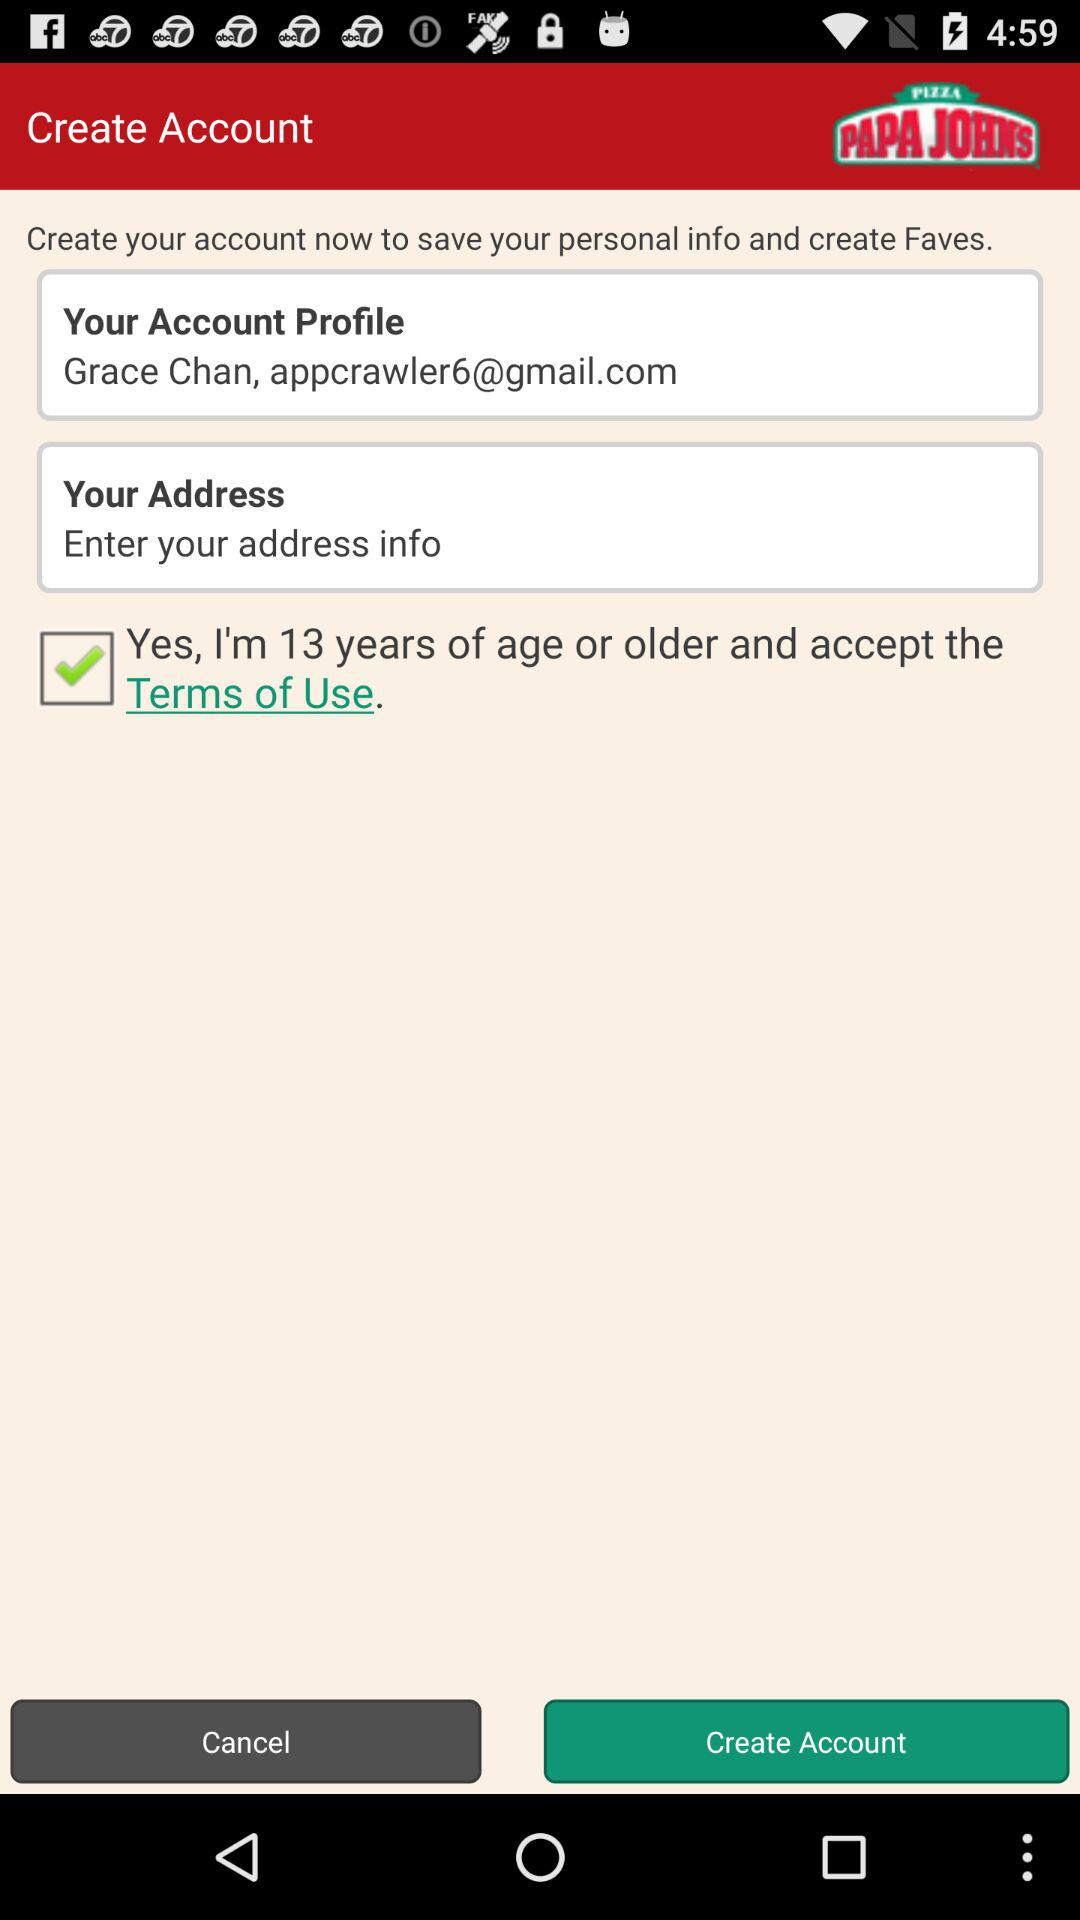What is the account profile? The account profile is Grace Chan, appcrawler6@gmail.com. 